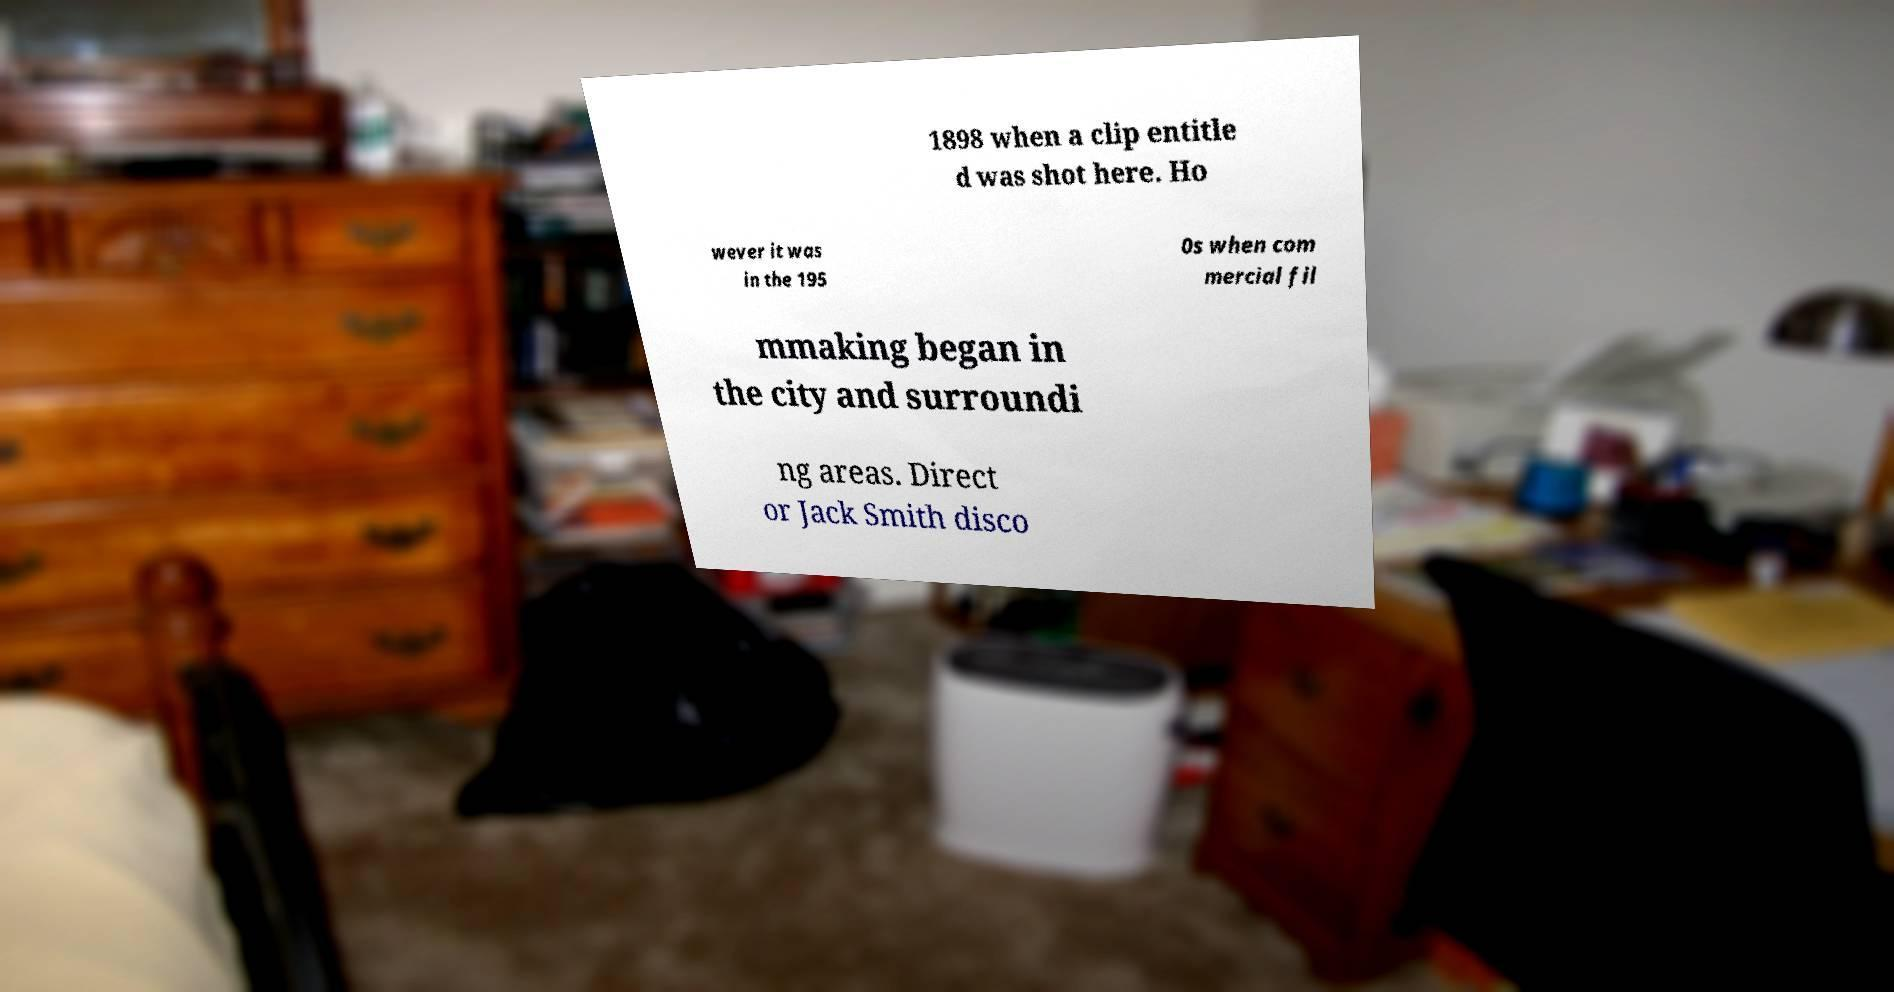I need the written content from this picture converted into text. Can you do that? 1898 when a clip entitle d was shot here. Ho wever it was in the 195 0s when com mercial fil mmaking began in the city and surroundi ng areas. Direct or Jack Smith disco 